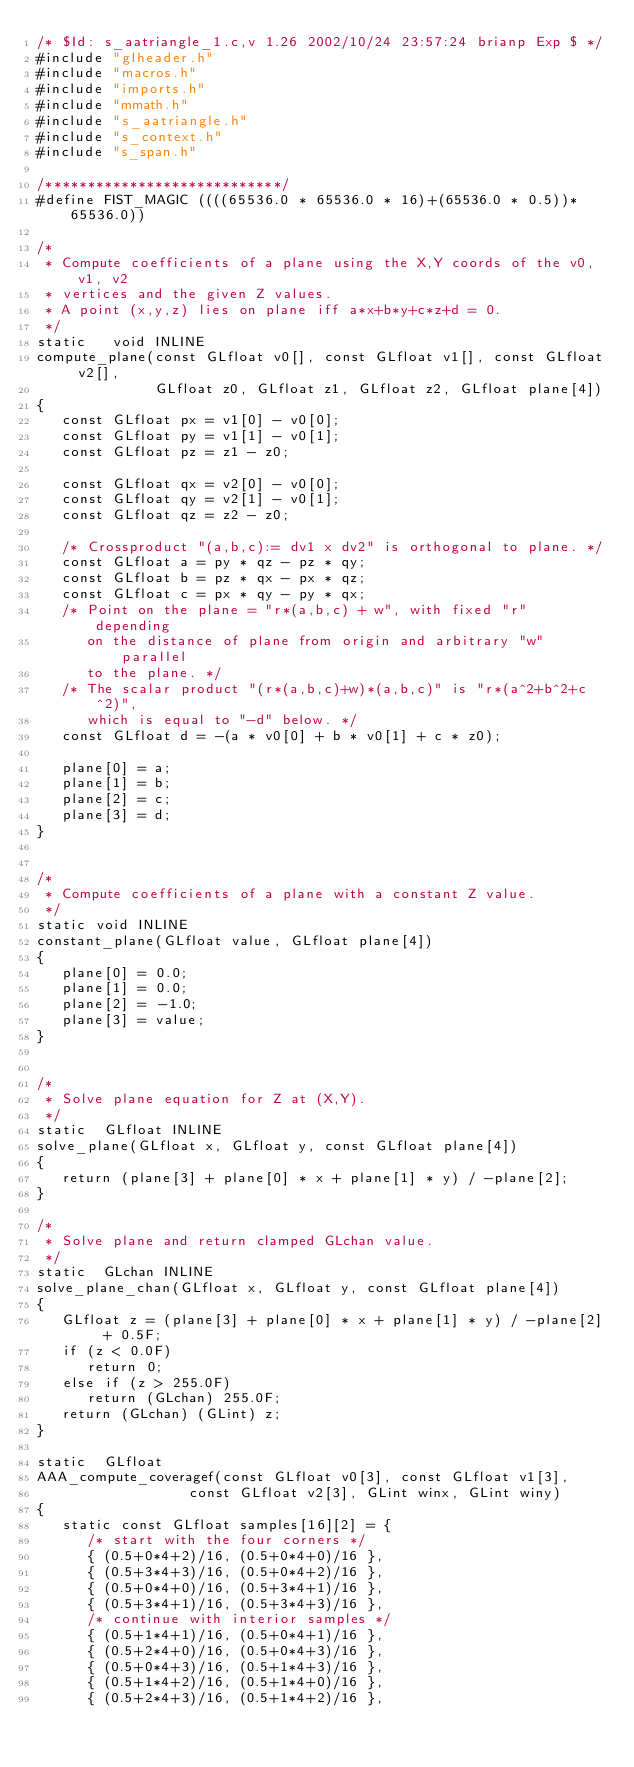Convert code to text. <code><loc_0><loc_0><loc_500><loc_500><_C++_>/* $Id: s_aatriangle_1.c,v 1.26 2002/10/24 23:57:24 brianp Exp $ */
#include "glheader.h"
#include "macros.h"
#include "imports.h"
#include "mmath.h"
#include "s_aatriangle.h"
#include "s_context.h"
#include "s_span.h"

/****************************/
#define FIST_MAGIC ((((65536.0 * 65536.0 * 16)+(65536.0 * 0.5))* 65536.0))

/*
 * Compute coefficients of a plane using the X,Y coords of the v0, v1, v2
 * vertices and the given Z values.
 * A point (x,y,z) lies on plane iff a*x+b*y+c*z+d = 0.
 */
static   void INLINE
compute_plane(const GLfloat v0[], const GLfloat v1[], const GLfloat v2[],
              GLfloat z0, GLfloat z1, GLfloat z2, GLfloat plane[4])
{
   const GLfloat px = v1[0] - v0[0];
   const GLfloat py = v1[1] - v0[1];
   const GLfloat pz = z1 - z0;

   const GLfloat qx = v2[0] - v0[0];
   const GLfloat qy = v2[1] - v0[1];
   const GLfloat qz = z2 - z0;

   /* Crossproduct "(a,b,c):= dv1 x dv2" is orthogonal to plane. */
   const GLfloat a = py * qz - pz * qy;
   const GLfloat b = pz * qx - px * qz;
   const GLfloat c = px * qy - py * qx;
   /* Point on the plane = "r*(a,b,c) + w", with fixed "r" depending
      on the distance of plane from origin and arbitrary "w" parallel
      to the plane. */
   /* The scalar product "(r*(a,b,c)+w)*(a,b,c)" is "r*(a^2+b^2+c^2)",
      which is equal to "-d" below. */
   const GLfloat d = -(a * v0[0] + b * v0[1] + c * z0);

   plane[0] = a;
   plane[1] = b;
   plane[2] = c;
   plane[3] = d;
}


/*
 * Compute coefficients of a plane with a constant Z value.
 */
static void INLINE
constant_plane(GLfloat value, GLfloat plane[4])
{
   plane[0] = 0.0;
   plane[1] = 0.0;
   plane[2] = -1.0;
   plane[3] = value;
}


/*
 * Solve plane equation for Z at (X,Y).
 */
static  GLfloat INLINE
solve_plane(GLfloat x, GLfloat y, const GLfloat plane[4])
{
   return (plane[3] + plane[0] * x + plane[1] * y) / -plane[2];
}

/*
 * Solve plane and return clamped GLchan value.
 */
static  GLchan INLINE
solve_plane_chan(GLfloat x, GLfloat y, const GLfloat plane[4])
{
   GLfloat z = (plane[3] + plane[0] * x + plane[1] * y) / -plane[2] + 0.5F;
   if (z < 0.0F)
      return 0;
   else if (z > 255.0F)
      return (GLchan) 255.0F;
   return (GLchan) (GLint) z;
}

static  GLfloat
AAA_compute_coveragef(const GLfloat v0[3], const GLfloat v1[3],
                  const GLfloat v2[3], GLint winx, GLint winy)
{
   static const GLfloat samples[16][2] = {
      /* start with the four corners */
      { (0.5+0*4+2)/16, (0.5+0*4+0)/16 },
      { (0.5+3*4+3)/16, (0.5+0*4+2)/16 },
      { (0.5+0*4+0)/16, (0.5+3*4+1)/16 },
      { (0.5+3*4+1)/16, (0.5+3*4+3)/16 },
      /* continue with interior samples */
      { (0.5+1*4+1)/16, (0.5+0*4+1)/16 },
      { (0.5+2*4+0)/16, (0.5+0*4+3)/16 },
      { (0.5+0*4+3)/16, (0.5+1*4+3)/16 },
      { (0.5+1*4+2)/16, (0.5+1*4+0)/16 },
      { (0.5+2*4+3)/16, (0.5+1*4+2)/16 },</code> 